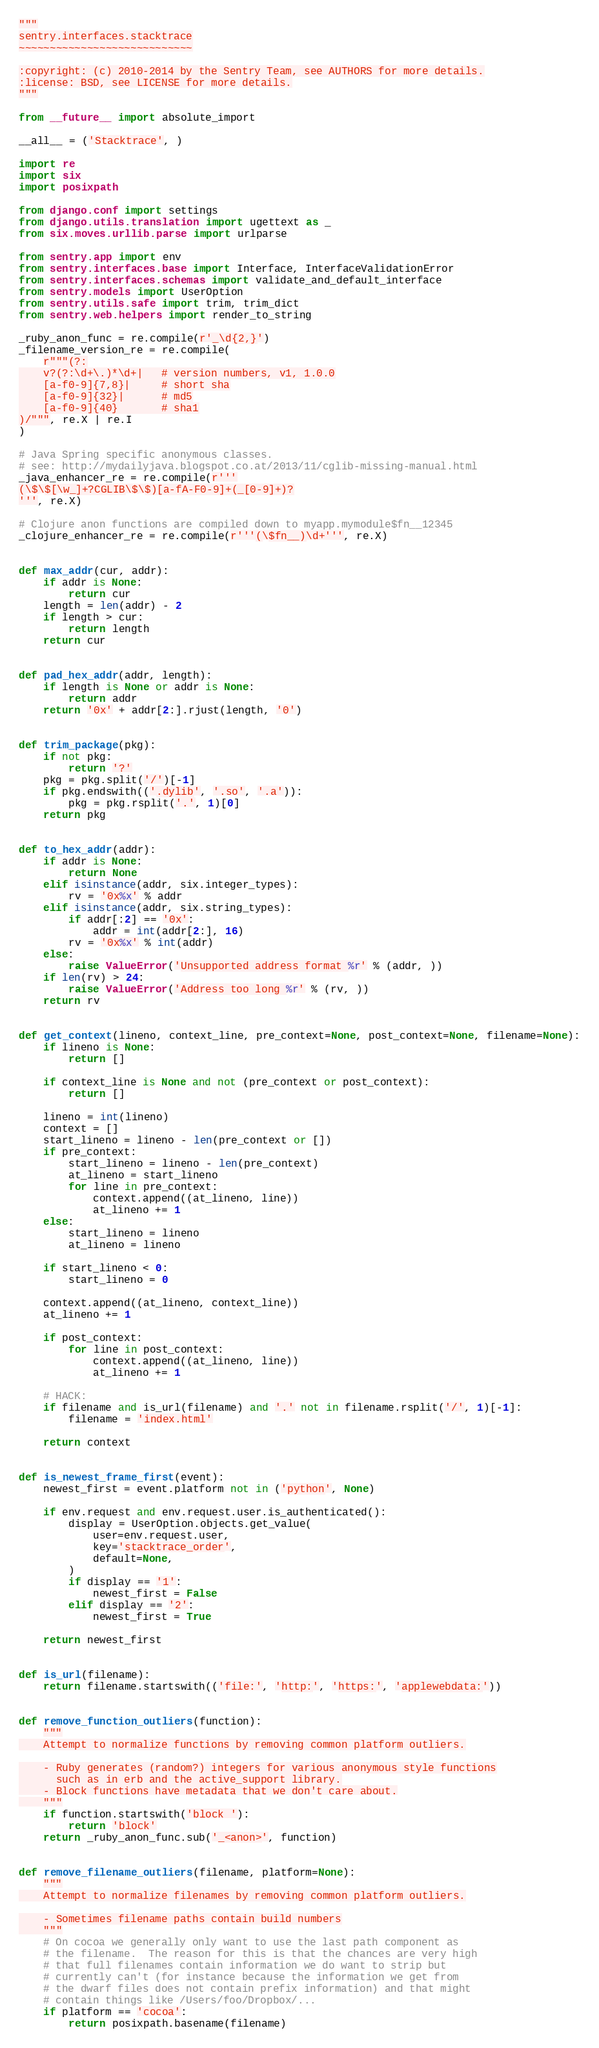Convert code to text. <code><loc_0><loc_0><loc_500><loc_500><_Python_>"""
sentry.interfaces.stacktrace
~~~~~~~~~~~~~~~~~~~~~~~~~~~~

:copyright: (c) 2010-2014 by the Sentry Team, see AUTHORS for more details.
:license: BSD, see LICENSE for more details.
"""

from __future__ import absolute_import

__all__ = ('Stacktrace', )

import re
import six
import posixpath

from django.conf import settings
from django.utils.translation import ugettext as _
from six.moves.urllib.parse import urlparse

from sentry.app import env
from sentry.interfaces.base import Interface, InterfaceValidationError
from sentry.interfaces.schemas import validate_and_default_interface
from sentry.models import UserOption
from sentry.utils.safe import trim, trim_dict
from sentry.web.helpers import render_to_string

_ruby_anon_func = re.compile(r'_\d{2,}')
_filename_version_re = re.compile(
    r"""(?:
    v?(?:\d+\.)*\d+|   # version numbers, v1, 1.0.0
    [a-f0-9]{7,8}|     # short sha
    [a-f0-9]{32}|      # md5
    [a-f0-9]{40}       # sha1
)/""", re.X | re.I
)

# Java Spring specific anonymous classes.
# see: http://mydailyjava.blogspot.co.at/2013/11/cglib-missing-manual.html
_java_enhancer_re = re.compile(r'''
(\$\$[\w_]+?CGLIB\$\$)[a-fA-F0-9]+(_[0-9]+)?
''', re.X)

# Clojure anon functions are compiled down to myapp.mymodule$fn__12345
_clojure_enhancer_re = re.compile(r'''(\$fn__)\d+''', re.X)


def max_addr(cur, addr):
    if addr is None:
        return cur
    length = len(addr) - 2
    if length > cur:
        return length
    return cur


def pad_hex_addr(addr, length):
    if length is None or addr is None:
        return addr
    return '0x' + addr[2:].rjust(length, '0')


def trim_package(pkg):
    if not pkg:
        return '?'
    pkg = pkg.split('/')[-1]
    if pkg.endswith(('.dylib', '.so', '.a')):
        pkg = pkg.rsplit('.', 1)[0]
    return pkg


def to_hex_addr(addr):
    if addr is None:
        return None
    elif isinstance(addr, six.integer_types):
        rv = '0x%x' % addr
    elif isinstance(addr, six.string_types):
        if addr[:2] == '0x':
            addr = int(addr[2:], 16)
        rv = '0x%x' % int(addr)
    else:
        raise ValueError('Unsupported address format %r' % (addr, ))
    if len(rv) > 24:
        raise ValueError('Address too long %r' % (rv, ))
    return rv


def get_context(lineno, context_line, pre_context=None, post_context=None, filename=None):
    if lineno is None:
        return []

    if context_line is None and not (pre_context or post_context):
        return []

    lineno = int(lineno)
    context = []
    start_lineno = lineno - len(pre_context or [])
    if pre_context:
        start_lineno = lineno - len(pre_context)
        at_lineno = start_lineno
        for line in pre_context:
            context.append((at_lineno, line))
            at_lineno += 1
    else:
        start_lineno = lineno
        at_lineno = lineno

    if start_lineno < 0:
        start_lineno = 0

    context.append((at_lineno, context_line))
    at_lineno += 1

    if post_context:
        for line in post_context:
            context.append((at_lineno, line))
            at_lineno += 1

    # HACK:
    if filename and is_url(filename) and '.' not in filename.rsplit('/', 1)[-1]:
        filename = 'index.html'

    return context


def is_newest_frame_first(event):
    newest_first = event.platform not in ('python', None)

    if env.request and env.request.user.is_authenticated():
        display = UserOption.objects.get_value(
            user=env.request.user,
            key='stacktrace_order',
            default=None,
        )
        if display == '1':
            newest_first = False
        elif display == '2':
            newest_first = True

    return newest_first


def is_url(filename):
    return filename.startswith(('file:', 'http:', 'https:', 'applewebdata:'))


def remove_function_outliers(function):
    """
    Attempt to normalize functions by removing common platform outliers.

    - Ruby generates (random?) integers for various anonymous style functions
      such as in erb and the active_support library.
    - Block functions have metadata that we don't care about.
    """
    if function.startswith('block '):
        return 'block'
    return _ruby_anon_func.sub('_<anon>', function)


def remove_filename_outliers(filename, platform=None):
    """
    Attempt to normalize filenames by removing common platform outliers.

    - Sometimes filename paths contain build numbers
    """
    # On cocoa we generally only want to use the last path component as
    # the filename.  The reason for this is that the chances are very high
    # that full filenames contain information we do want to strip but
    # currently can't (for instance because the information we get from
    # the dwarf files does not contain prefix information) and that might
    # contain things like /Users/foo/Dropbox/...
    if platform == 'cocoa':
        return posixpath.basename(filename)</code> 